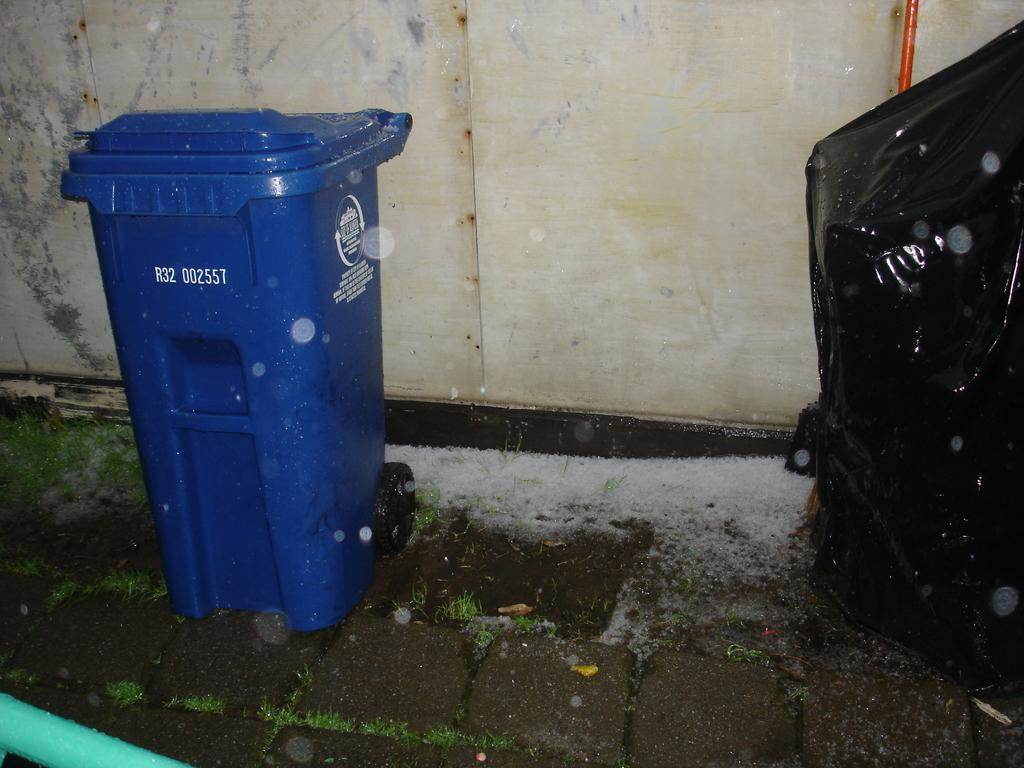Provide a one-sentence caption for the provided image. A blue recycling bin marked R32 002557 sits near a wall. 